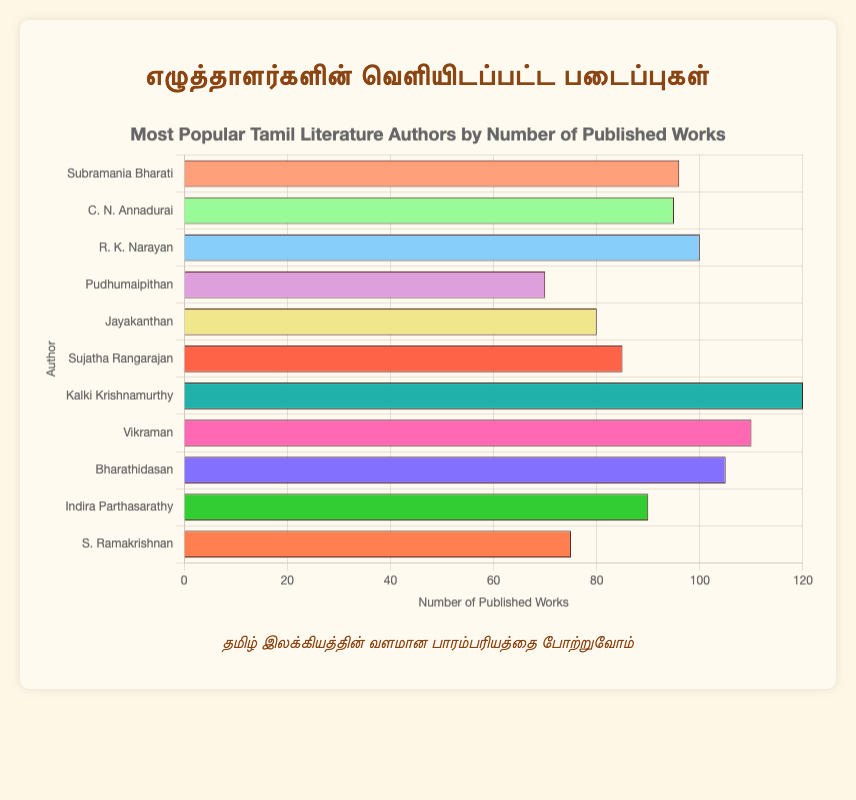Which author has the most published works? The figure shows each author and the number of their published works. The author with the longest bar represents the most published works.
Answer: Kalki Krishnamurthy Which author has fewer published works, Subramania Bharati or C. N. Annadurai? By comparing the lengths of the bars for Subramania Bharati and C. N. Annadurai, we see that C. N. Annadurai's bar is slightly shorter.
Answer: C. N. Annadurai How many more published works does Vikraman have compared to Jayakanthan? According to the figure, Vikraman has 110 published works and Jayakanthan has 80. Subtracting Jayakanthan's total from Vikraman's gives 110 - 80.
Answer: 30 What is the total number of published works by Sujatha Rangarajan, Indira Parthasarathy, and Jayakanthan combined? Summing up the number of published works for Sujatha Rangarajan (85), Indira Parthasarathy (90), and Jayakanthan (80) results in 85 + 90 + 80.
Answer: 255 Which author has a publication count nearest to 100? By examining the lengths of the bars around the 100 mark, R. K. Narayan (100) and Bharathidasan (105) are closest to 100. To determine "nearest," compare the differences:
Answer: R. K. Narayan How many authors have published more than 90 works? Count the bars with values greater than 90: Subramania Bharati (96), C. N. Annadurai (95), R. K. Narayan (100), Kalki Krishnamurthy (120), Vikraman (110), and Bharathidasan (105) make a total of 6 authors.
Answer: 6 What’s the difference in published works between the most prolific author and S. Ramakrishnan? The most prolific author, Kalki Krishnamurthy, has 120 published works. S. Ramakrishnan has 75. The difference is 120 - 75.
Answer: 45 What is the average number of published works among all the authors? Sum the number of published works for all authors and divide by the count of authors: (96+95+100+70+80+85+120+110+105+90+75) / 11. The total is 1026, and the average is 1026 / 11.
Answer: 93.27 Who has more published works, Pudhumaipithan or Jayakanthan? Comparing the bars for Pudhumaipithan (70) and Jayakanthan (80), Jayakanthan’s bar is longer.
Answer: Jayakanthan 